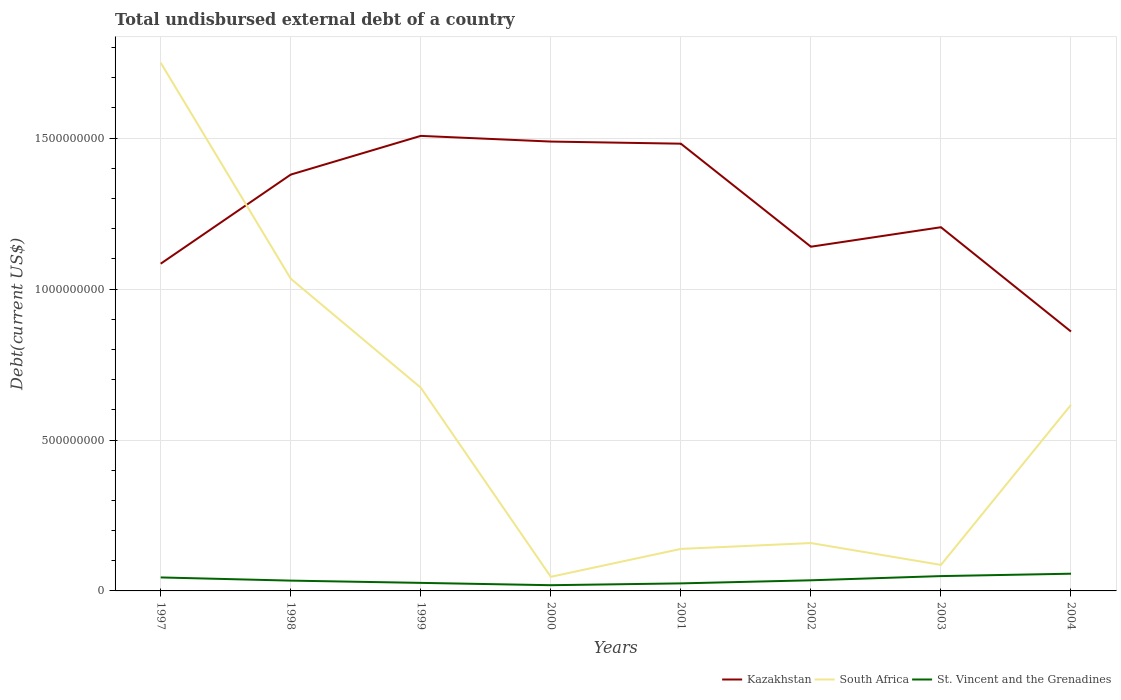Is the number of lines equal to the number of legend labels?
Ensure brevity in your answer.  Yes. Across all years, what is the maximum total undisbursed external debt in St. Vincent and the Grenadines?
Offer a terse response. 1.90e+07. In which year was the total undisbursed external debt in South Africa maximum?
Offer a terse response. 2000. What is the total total undisbursed external debt in South Africa in the graph?
Ensure brevity in your answer.  8.76e+08. What is the difference between the highest and the second highest total undisbursed external debt in Kazakhstan?
Your answer should be compact. 6.48e+08. How many years are there in the graph?
Keep it short and to the point. 8. What is the difference between two consecutive major ticks on the Y-axis?
Your answer should be very brief. 5.00e+08. Does the graph contain grids?
Offer a terse response. Yes. What is the title of the graph?
Give a very brief answer. Total undisbursed external debt of a country. Does "Sao Tome and Principe" appear as one of the legend labels in the graph?
Ensure brevity in your answer.  No. What is the label or title of the X-axis?
Provide a succinct answer. Years. What is the label or title of the Y-axis?
Offer a very short reply. Debt(current US$). What is the Debt(current US$) in Kazakhstan in 1997?
Your answer should be compact. 1.08e+09. What is the Debt(current US$) of South Africa in 1997?
Make the answer very short. 1.75e+09. What is the Debt(current US$) in St. Vincent and the Grenadines in 1997?
Keep it short and to the point. 4.47e+07. What is the Debt(current US$) in Kazakhstan in 1998?
Give a very brief answer. 1.38e+09. What is the Debt(current US$) in South Africa in 1998?
Provide a short and direct response. 1.03e+09. What is the Debt(current US$) of St. Vincent and the Grenadines in 1998?
Provide a succinct answer. 3.41e+07. What is the Debt(current US$) in Kazakhstan in 1999?
Offer a very short reply. 1.51e+09. What is the Debt(current US$) in South Africa in 1999?
Offer a terse response. 6.73e+08. What is the Debt(current US$) of St. Vincent and the Grenadines in 1999?
Offer a very short reply. 2.66e+07. What is the Debt(current US$) of Kazakhstan in 2000?
Provide a short and direct response. 1.49e+09. What is the Debt(current US$) of South Africa in 2000?
Give a very brief answer. 4.67e+07. What is the Debt(current US$) in St. Vincent and the Grenadines in 2000?
Your answer should be compact. 1.90e+07. What is the Debt(current US$) of Kazakhstan in 2001?
Make the answer very short. 1.48e+09. What is the Debt(current US$) of South Africa in 2001?
Provide a succinct answer. 1.39e+08. What is the Debt(current US$) of St. Vincent and the Grenadines in 2001?
Give a very brief answer. 2.50e+07. What is the Debt(current US$) in Kazakhstan in 2002?
Provide a succinct answer. 1.14e+09. What is the Debt(current US$) of South Africa in 2002?
Offer a terse response. 1.59e+08. What is the Debt(current US$) in St. Vincent and the Grenadines in 2002?
Offer a very short reply. 3.52e+07. What is the Debt(current US$) in Kazakhstan in 2003?
Your answer should be very brief. 1.20e+09. What is the Debt(current US$) of South Africa in 2003?
Your answer should be compact. 8.62e+07. What is the Debt(current US$) in St. Vincent and the Grenadines in 2003?
Provide a succinct answer. 4.91e+07. What is the Debt(current US$) of Kazakhstan in 2004?
Offer a terse response. 8.59e+08. What is the Debt(current US$) in South Africa in 2004?
Your answer should be very brief. 6.16e+08. What is the Debt(current US$) of St. Vincent and the Grenadines in 2004?
Ensure brevity in your answer.  5.70e+07. Across all years, what is the maximum Debt(current US$) in Kazakhstan?
Ensure brevity in your answer.  1.51e+09. Across all years, what is the maximum Debt(current US$) in South Africa?
Keep it short and to the point. 1.75e+09. Across all years, what is the maximum Debt(current US$) of St. Vincent and the Grenadines?
Your response must be concise. 5.70e+07. Across all years, what is the minimum Debt(current US$) in Kazakhstan?
Your answer should be compact. 8.59e+08. Across all years, what is the minimum Debt(current US$) in South Africa?
Provide a short and direct response. 4.67e+07. Across all years, what is the minimum Debt(current US$) in St. Vincent and the Grenadines?
Your answer should be compact. 1.90e+07. What is the total Debt(current US$) in Kazakhstan in the graph?
Offer a terse response. 1.01e+1. What is the total Debt(current US$) of South Africa in the graph?
Keep it short and to the point. 4.50e+09. What is the total Debt(current US$) in St. Vincent and the Grenadines in the graph?
Ensure brevity in your answer.  2.91e+08. What is the difference between the Debt(current US$) in Kazakhstan in 1997 and that in 1998?
Offer a terse response. -2.95e+08. What is the difference between the Debt(current US$) in South Africa in 1997 and that in 1998?
Your answer should be compact. 7.16e+08. What is the difference between the Debt(current US$) in St. Vincent and the Grenadines in 1997 and that in 1998?
Your answer should be compact. 1.05e+07. What is the difference between the Debt(current US$) in Kazakhstan in 1997 and that in 1999?
Give a very brief answer. -4.23e+08. What is the difference between the Debt(current US$) of South Africa in 1997 and that in 1999?
Give a very brief answer. 1.08e+09. What is the difference between the Debt(current US$) in St. Vincent and the Grenadines in 1997 and that in 1999?
Your response must be concise. 1.80e+07. What is the difference between the Debt(current US$) in Kazakhstan in 1997 and that in 2000?
Your response must be concise. -4.05e+08. What is the difference between the Debt(current US$) of South Africa in 1997 and that in 2000?
Provide a succinct answer. 1.70e+09. What is the difference between the Debt(current US$) in St. Vincent and the Grenadines in 1997 and that in 2000?
Your answer should be compact. 2.57e+07. What is the difference between the Debt(current US$) in Kazakhstan in 1997 and that in 2001?
Your answer should be compact. -3.98e+08. What is the difference between the Debt(current US$) of South Africa in 1997 and that in 2001?
Offer a terse response. 1.61e+09. What is the difference between the Debt(current US$) in St. Vincent and the Grenadines in 1997 and that in 2001?
Your response must be concise. 1.97e+07. What is the difference between the Debt(current US$) in Kazakhstan in 1997 and that in 2002?
Give a very brief answer. -5.63e+07. What is the difference between the Debt(current US$) in South Africa in 1997 and that in 2002?
Give a very brief answer. 1.59e+09. What is the difference between the Debt(current US$) in St. Vincent and the Grenadines in 1997 and that in 2002?
Offer a very short reply. 9.50e+06. What is the difference between the Debt(current US$) of Kazakhstan in 1997 and that in 2003?
Provide a short and direct response. -1.21e+08. What is the difference between the Debt(current US$) of South Africa in 1997 and that in 2003?
Make the answer very short. 1.66e+09. What is the difference between the Debt(current US$) of St. Vincent and the Grenadines in 1997 and that in 2003?
Your response must be concise. -4.47e+06. What is the difference between the Debt(current US$) of Kazakhstan in 1997 and that in 2004?
Offer a terse response. 2.25e+08. What is the difference between the Debt(current US$) of South Africa in 1997 and that in 2004?
Your answer should be compact. 1.13e+09. What is the difference between the Debt(current US$) of St. Vincent and the Grenadines in 1997 and that in 2004?
Give a very brief answer. -1.24e+07. What is the difference between the Debt(current US$) in Kazakhstan in 1998 and that in 1999?
Provide a short and direct response. -1.28e+08. What is the difference between the Debt(current US$) of South Africa in 1998 and that in 1999?
Give a very brief answer. 3.61e+08. What is the difference between the Debt(current US$) of St. Vincent and the Grenadines in 1998 and that in 1999?
Give a very brief answer. 7.50e+06. What is the difference between the Debt(current US$) in Kazakhstan in 1998 and that in 2000?
Give a very brief answer. -1.09e+08. What is the difference between the Debt(current US$) in South Africa in 1998 and that in 2000?
Provide a succinct answer. 9.88e+08. What is the difference between the Debt(current US$) of St. Vincent and the Grenadines in 1998 and that in 2000?
Keep it short and to the point. 1.52e+07. What is the difference between the Debt(current US$) in Kazakhstan in 1998 and that in 2001?
Your response must be concise. -1.02e+08. What is the difference between the Debt(current US$) in South Africa in 1998 and that in 2001?
Ensure brevity in your answer.  8.95e+08. What is the difference between the Debt(current US$) of St. Vincent and the Grenadines in 1998 and that in 2001?
Your answer should be compact. 9.16e+06. What is the difference between the Debt(current US$) of Kazakhstan in 1998 and that in 2002?
Provide a succinct answer. 2.39e+08. What is the difference between the Debt(current US$) of South Africa in 1998 and that in 2002?
Your answer should be very brief. 8.76e+08. What is the difference between the Debt(current US$) in St. Vincent and the Grenadines in 1998 and that in 2002?
Your answer should be very brief. -1.04e+06. What is the difference between the Debt(current US$) of Kazakhstan in 1998 and that in 2003?
Ensure brevity in your answer.  1.74e+08. What is the difference between the Debt(current US$) in South Africa in 1998 and that in 2003?
Provide a succinct answer. 9.48e+08. What is the difference between the Debt(current US$) in St. Vincent and the Grenadines in 1998 and that in 2003?
Offer a terse response. -1.50e+07. What is the difference between the Debt(current US$) of Kazakhstan in 1998 and that in 2004?
Your answer should be very brief. 5.20e+08. What is the difference between the Debt(current US$) of South Africa in 1998 and that in 2004?
Give a very brief answer. 4.18e+08. What is the difference between the Debt(current US$) in St. Vincent and the Grenadines in 1998 and that in 2004?
Your response must be concise. -2.29e+07. What is the difference between the Debt(current US$) of Kazakhstan in 1999 and that in 2000?
Your answer should be compact. 1.88e+07. What is the difference between the Debt(current US$) of South Africa in 1999 and that in 2000?
Your answer should be compact. 6.27e+08. What is the difference between the Debt(current US$) in St. Vincent and the Grenadines in 1999 and that in 2000?
Ensure brevity in your answer.  7.69e+06. What is the difference between the Debt(current US$) of Kazakhstan in 1999 and that in 2001?
Offer a very short reply. 2.59e+07. What is the difference between the Debt(current US$) of South Africa in 1999 and that in 2001?
Offer a terse response. 5.34e+08. What is the difference between the Debt(current US$) in St. Vincent and the Grenadines in 1999 and that in 2001?
Offer a very short reply. 1.66e+06. What is the difference between the Debt(current US$) in Kazakhstan in 1999 and that in 2002?
Provide a short and direct response. 3.67e+08. What is the difference between the Debt(current US$) of South Africa in 1999 and that in 2002?
Your response must be concise. 5.15e+08. What is the difference between the Debt(current US$) in St. Vincent and the Grenadines in 1999 and that in 2002?
Keep it short and to the point. -8.54e+06. What is the difference between the Debt(current US$) in Kazakhstan in 1999 and that in 2003?
Ensure brevity in your answer.  3.03e+08. What is the difference between the Debt(current US$) of South Africa in 1999 and that in 2003?
Keep it short and to the point. 5.87e+08. What is the difference between the Debt(current US$) of St. Vincent and the Grenadines in 1999 and that in 2003?
Offer a terse response. -2.25e+07. What is the difference between the Debt(current US$) of Kazakhstan in 1999 and that in 2004?
Make the answer very short. 6.48e+08. What is the difference between the Debt(current US$) in South Africa in 1999 and that in 2004?
Your response must be concise. 5.69e+07. What is the difference between the Debt(current US$) of St. Vincent and the Grenadines in 1999 and that in 2004?
Offer a terse response. -3.04e+07. What is the difference between the Debt(current US$) of Kazakhstan in 2000 and that in 2001?
Your answer should be very brief. 7.06e+06. What is the difference between the Debt(current US$) of South Africa in 2000 and that in 2001?
Your response must be concise. -9.24e+07. What is the difference between the Debt(current US$) of St. Vincent and the Grenadines in 2000 and that in 2001?
Keep it short and to the point. -6.02e+06. What is the difference between the Debt(current US$) in Kazakhstan in 2000 and that in 2002?
Keep it short and to the point. 3.48e+08. What is the difference between the Debt(current US$) of South Africa in 2000 and that in 2002?
Make the answer very short. -1.12e+08. What is the difference between the Debt(current US$) in St. Vincent and the Grenadines in 2000 and that in 2002?
Your answer should be very brief. -1.62e+07. What is the difference between the Debt(current US$) in Kazakhstan in 2000 and that in 2003?
Your answer should be very brief. 2.84e+08. What is the difference between the Debt(current US$) in South Africa in 2000 and that in 2003?
Give a very brief answer. -3.94e+07. What is the difference between the Debt(current US$) in St. Vincent and the Grenadines in 2000 and that in 2003?
Provide a short and direct response. -3.02e+07. What is the difference between the Debt(current US$) of Kazakhstan in 2000 and that in 2004?
Offer a very short reply. 6.29e+08. What is the difference between the Debt(current US$) in South Africa in 2000 and that in 2004?
Offer a very short reply. -5.70e+08. What is the difference between the Debt(current US$) of St. Vincent and the Grenadines in 2000 and that in 2004?
Your answer should be compact. -3.81e+07. What is the difference between the Debt(current US$) of Kazakhstan in 2001 and that in 2002?
Offer a terse response. 3.41e+08. What is the difference between the Debt(current US$) of South Africa in 2001 and that in 2002?
Offer a very short reply. -1.94e+07. What is the difference between the Debt(current US$) in St. Vincent and the Grenadines in 2001 and that in 2002?
Make the answer very short. -1.02e+07. What is the difference between the Debt(current US$) in Kazakhstan in 2001 and that in 2003?
Your answer should be compact. 2.77e+08. What is the difference between the Debt(current US$) of South Africa in 2001 and that in 2003?
Provide a succinct answer. 5.30e+07. What is the difference between the Debt(current US$) of St. Vincent and the Grenadines in 2001 and that in 2003?
Your answer should be very brief. -2.42e+07. What is the difference between the Debt(current US$) of Kazakhstan in 2001 and that in 2004?
Provide a succinct answer. 6.22e+08. What is the difference between the Debt(current US$) of South Africa in 2001 and that in 2004?
Make the answer very short. -4.77e+08. What is the difference between the Debt(current US$) of St. Vincent and the Grenadines in 2001 and that in 2004?
Your answer should be compact. -3.21e+07. What is the difference between the Debt(current US$) of Kazakhstan in 2002 and that in 2003?
Ensure brevity in your answer.  -6.46e+07. What is the difference between the Debt(current US$) of South Africa in 2002 and that in 2003?
Keep it short and to the point. 7.24e+07. What is the difference between the Debt(current US$) in St. Vincent and the Grenadines in 2002 and that in 2003?
Your answer should be very brief. -1.40e+07. What is the difference between the Debt(current US$) in Kazakhstan in 2002 and that in 2004?
Provide a succinct answer. 2.81e+08. What is the difference between the Debt(current US$) in South Africa in 2002 and that in 2004?
Offer a terse response. -4.58e+08. What is the difference between the Debt(current US$) of St. Vincent and the Grenadines in 2002 and that in 2004?
Provide a short and direct response. -2.19e+07. What is the difference between the Debt(current US$) in Kazakhstan in 2003 and that in 2004?
Your response must be concise. 3.46e+08. What is the difference between the Debt(current US$) in South Africa in 2003 and that in 2004?
Keep it short and to the point. -5.30e+08. What is the difference between the Debt(current US$) in St. Vincent and the Grenadines in 2003 and that in 2004?
Keep it short and to the point. -7.89e+06. What is the difference between the Debt(current US$) of Kazakhstan in 1997 and the Debt(current US$) of South Africa in 1998?
Offer a very short reply. 4.96e+07. What is the difference between the Debt(current US$) of Kazakhstan in 1997 and the Debt(current US$) of St. Vincent and the Grenadines in 1998?
Your answer should be very brief. 1.05e+09. What is the difference between the Debt(current US$) in South Africa in 1997 and the Debt(current US$) in St. Vincent and the Grenadines in 1998?
Give a very brief answer. 1.72e+09. What is the difference between the Debt(current US$) in Kazakhstan in 1997 and the Debt(current US$) in South Africa in 1999?
Provide a succinct answer. 4.11e+08. What is the difference between the Debt(current US$) in Kazakhstan in 1997 and the Debt(current US$) in St. Vincent and the Grenadines in 1999?
Keep it short and to the point. 1.06e+09. What is the difference between the Debt(current US$) of South Africa in 1997 and the Debt(current US$) of St. Vincent and the Grenadines in 1999?
Offer a very short reply. 1.72e+09. What is the difference between the Debt(current US$) of Kazakhstan in 1997 and the Debt(current US$) of South Africa in 2000?
Give a very brief answer. 1.04e+09. What is the difference between the Debt(current US$) in Kazakhstan in 1997 and the Debt(current US$) in St. Vincent and the Grenadines in 2000?
Keep it short and to the point. 1.07e+09. What is the difference between the Debt(current US$) of South Africa in 1997 and the Debt(current US$) of St. Vincent and the Grenadines in 2000?
Provide a succinct answer. 1.73e+09. What is the difference between the Debt(current US$) in Kazakhstan in 1997 and the Debt(current US$) in South Africa in 2001?
Ensure brevity in your answer.  9.45e+08. What is the difference between the Debt(current US$) in Kazakhstan in 1997 and the Debt(current US$) in St. Vincent and the Grenadines in 2001?
Offer a terse response. 1.06e+09. What is the difference between the Debt(current US$) of South Africa in 1997 and the Debt(current US$) of St. Vincent and the Grenadines in 2001?
Provide a succinct answer. 1.73e+09. What is the difference between the Debt(current US$) in Kazakhstan in 1997 and the Debt(current US$) in South Africa in 2002?
Keep it short and to the point. 9.26e+08. What is the difference between the Debt(current US$) of Kazakhstan in 1997 and the Debt(current US$) of St. Vincent and the Grenadines in 2002?
Provide a succinct answer. 1.05e+09. What is the difference between the Debt(current US$) in South Africa in 1997 and the Debt(current US$) in St. Vincent and the Grenadines in 2002?
Keep it short and to the point. 1.71e+09. What is the difference between the Debt(current US$) of Kazakhstan in 1997 and the Debt(current US$) of South Africa in 2003?
Give a very brief answer. 9.98e+08. What is the difference between the Debt(current US$) in Kazakhstan in 1997 and the Debt(current US$) in St. Vincent and the Grenadines in 2003?
Keep it short and to the point. 1.03e+09. What is the difference between the Debt(current US$) in South Africa in 1997 and the Debt(current US$) in St. Vincent and the Grenadines in 2003?
Offer a very short reply. 1.70e+09. What is the difference between the Debt(current US$) in Kazakhstan in 1997 and the Debt(current US$) in South Africa in 2004?
Keep it short and to the point. 4.68e+08. What is the difference between the Debt(current US$) of Kazakhstan in 1997 and the Debt(current US$) of St. Vincent and the Grenadines in 2004?
Your answer should be compact. 1.03e+09. What is the difference between the Debt(current US$) in South Africa in 1997 and the Debt(current US$) in St. Vincent and the Grenadines in 2004?
Make the answer very short. 1.69e+09. What is the difference between the Debt(current US$) of Kazakhstan in 1998 and the Debt(current US$) of South Africa in 1999?
Ensure brevity in your answer.  7.06e+08. What is the difference between the Debt(current US$) in Kazakhstan in 1998 and the Debt(current US$) in St. Vincent and the Grenadines in 1999?
Provide a succinct answer. 1.35e+09. What is the difference between the Debt(current US$) in South Africa in 1998 and the Debt(current US$) in St. Vincent and the Grenadines in 1999?
Provide a short and direct response. 1.01e+09. What is the difference between the Debt(current US$) of Kazakhstan in 1998 and the Debt(current US$) of South Africa in 2000?
Ensure brevity in your answer.  1.33e+09. What is the difference between the Debt(current US$) in Kazakhstan in 1998 and the Debt(current US$) in St. Vincent and the Grenadines in 2000?
Give a very brief answer. 1.36e+09. What is the difference between the Debt(current US$) in South Africa in 1998 and the Debt(current US$) in St. Vincent and the Grenadines in 2000?
Provide a succinct answer. 1.02e+09. What is the difference between the Debt(current US$) of Kazakhstan in 1998 and the Debt(current US$) of South Africa in 2001?
Your response must be concise. 1.24e+09. What is the difference between the Debt(current US$) in Kazakhstan in 1998 and the Debt(current US$) in St. Vincent and the Grenadines in 2001?
Give a very brief answer. 1.35e+09. What is the difference between the Debt(current US$) of South Africa in 1998 and the Debt(current US$) of St. Vincent and the Grenadines in 2001?
Offer a very short reply. 1.01e+09. What is the difference between the Debt(current US$) in Kazakhstan in 1998 and the Debt(current US$) in South Africa in 2002?
Keep it short and to the point. 1.22e+09. What is the difference between the Debt(current US$) of Kazakhstan in 1998 and the Debt(current US$) of St. Vincent and the Grenadines in 2002?
Your answer should be very brief. 1.34e+09. What is the difference between the Debt(current US$) in South Africa in 1998 and the Debt(current US$) in St. Vincent and the Grenadines in 2002?
Offer a very short reply. 9.99e+08. What is the difference between the Debt(current US$) in Kazakhstan in 1998 and the Debt(current US$) in South Africa in 2003?
Give a very brief answer. 1.29e+09. What is the difference between the Debt(current US$) in Kazakhstan in 1998 and the Debt(current US$) in St. Vincent and the Grenadines in 2003?
Give a very brief answer. 1.33e+09. What is the difference between the Debt(current US$) of South Africa in 1998 and the Debt(current US$) of St. Vincent and the Grenadines in 2003?
Give a very brief answer. 9.85e+08. What is the difference between the Debt(current US$) of Kazakhstan in 1998 and the Debt(current US$) of South Africa in 2004?
Provide a succinct answer. 7.63e+08. What is the difference between the Debt(current US$) of Kazakhstan in 1998 and the Debt(current US$) of St. Vincent and the Grenadines in 2004?
Provide a short and direct response. 1.32e+09. What is the difference between the Debt(current US$) in South Africa in 1998 and the Debt(current US$) in St. Vincent and the Grenadines in 2004?
Offer a terse response. 9.77e+08. What is the difference between the Debt(current US$) of Kazakhstan in 1999 and the Debt(current US$) of South Africa in 2000?
Keep it short and to the point. 1.46e+09. What is the difference between the Debt(current US$) of Kazakhstan in 1999 and the Debt(current US$) of St. Vincent and the Grenadines in 2000?
Give a very brief answer. 1.49e+09. What is the difference between the Debt(current US$) in South Africa in 1999 and the Debt(current US$) in St. Vincent and the Grenadines in 2000?
Provide a succinct answer. 6.54e+08. What is the difference between the Debt(current US$) in Kazakhstan in 1999 and the Debt(current US$) in South Africa in 2001?
Ensure brevity in your answer.  1.37e+09. What is the difference between the Debt(current US$) in Kazakhstan in 1999 and the Debt(current US$) in St. Vincent and the Grenadines in 2001?
Give a very brief answer. 1.48e+09. What is the difference between the Debt(current US$) of South Africa in 1999 and the Debt(current US$) of St. Vincent and the Grenadines in 2001?
Provide a short and direct response. 6.48e+08. What is the difference between the Debt(current US$) of Kazakhstan in 1999 and the Debt(current US$) of South Africa in 2002?
Make the answer very short. 1.35e+09. What is the difference between the Debt(current US$) of Kazakhstan in 1999 and the Debt(current US$) of St. Vincent and the Grenadines in 2002?
Ensure brevity in your answer.  1.47e+09. What is the difference between the Debt(current US$) of South Africa in 1999 and the Debt(current US$) of St. Vincent and the Grenadines in 2002?
Provide a short and direct response. 6.38e+08. What is the difference between the Debt(current US$) in Kazakhstan in 1999 and the Debt(current US$) in South Africa in 2003?
Your answer should be very brief. 1.42e+09. What is the difference between the Debt(current US$) in Kazakhstan in 1999 and the Debt(current US$) in St. Vincent and the Grenadines in 2003?
Provide a succinct answer. 1.46e+09. What is the difference between the Debt(current US$) of South Africa in 1999 and the Debt(current US$) of St. Vincent and the Grenadines in 2003?
Your answer should be very brief. 6.24e+08. What is the difference between the Debt(current US$) of Kazakhstan in 1999 and the Debt(current US$) of South Africa in 2004?
Make the answer very short. 8.91e+08. What is the difference between the Debt(current US$) of Kazakhstan in 1999 and the Debt(current US$) of St. Vincent and the Grenadines in 2004?
Offer a terse response. 1.45e+09. What is the difference between the Debt(current US$) in South Africa in 1999 and the Debt(current US$) in St. Vincent and the Grenadines in 2004?
Ensure brevity in your answer.  6.16e+08. What is the difference between the Debt(current US$) in Kazakhstan in 2000 and the Debt(current US$) in South Africa in 2001?
Provide a short and direct response. 1.35e+09. What is the difference between the Debt(current US$) of Kazakhstan in 2000 and the Debt(current US$) of St. Vincent and the Grenadines in 2001?
Your answer should be very brief. 1.46e+09. What is the difference between the Debt(current US$) of South Africa in 2000 and the Debt(current US$) of St. Vincent and the Grenadines in 2001?
Provide a short and direct response. 2.18e+07. What is the difference between the Debt(current US$) of Kazakhstan in 2000 and the Debt(current US$) of South Africa in 2002?
Provide a succinct answer. 1.33e+09. What is the difference between the Debt(current US$) in Kazakhstan in 2000 and the Debt(current US$) in St. Vincent and the Grenadines in 2002?
Ensure brevity in your answer.  1.45e+09. What is the difference between the Debt(current US$) in South Africa in 2000 and the Debt(current US$) in St. Vincent and the Grenadines in 2002?
Offer a very short reply. 1.16e+07. What is the difference between the Debt(current US$) of Kazakhstan in 2000 and the Debt(current US$) of South Africa in 2003?
Your answer should be very brief. 1.40e+09. What is the difference between the Debt(current US$) in Kazakhstan in 2000 and the Debt(current US$) in St. Vincent and the Grenadines in 2003?
Keep it short and to the point. 1.44e+09. What is the difference between the Debt(current US$) in South Africa in 2000 and the Debt(current US$) in St. Vincent and the Grenadines in 2003?
Your answer should be very brief. -2.40e+06. What is the difference between the Debt(current US$) in Kazakhstan in 2000 and the Debt(current US$) in South Africa in 2004?
Make the answer very short. 8.72e+08. What is the difference between the Debt(current US$) in Kazakhstan in 2000 and the Debt(current US$) in St. Vincent and the Grenadines in 2004?
Provide a succinct answer. 1.43e+09. What is the difference between the Debt(current US$) of South Africa in 2000 and the Debt(current US$) of St. Vincent and the Grenadines in 2004?
Offer a very short reply. -1.03e+07. What is the difference between the Debt(current US$) in Kazakhstan in 2001 and the Debt(current US$) in South Africa in 2002?
Offer a terse response. 1.32e+09. What is the difference between the Debt(current US$) in Kazakhstan in 2001 and the Debt(current US$) in St. Vincent and the Grenadines in 2002?
Give a very brief answer. 1.45e+09. What is the difference between the Debt(current US$) in South Africa in 2001 and the Debt(current US$) in St. Vincent and the Grenadines in 2002?
Keep it short and to the point. 1.04e+08. What is the difference between the Debt(current US$) in Kazakhstan in 2001 and the Debt(current US$) in South Africa in 2003?
Your response must be concise. 1.40e+09. What is the difference between the Debt(current US$) of Kazakhstan in 2001 and the Debt(current US$) of St. Vincent and the Grenadines in 2003?
Your answer should be compact. 1.43e+09. What is the difference between the Debt(current US$) in South Africa in 2001 and the Debt(current US$) in St. Vincent and the Grenadines in 2003?
Provide a short and direct response. 9.00e+07. What is the difference between the Debt(current US$) of Kazakhstan in 2001 and the Debt(current US$) of South Africa in 2004?
Offer a terse response. 8.65e+08. What is the difference between the Debt(current US$) of Kazakhstan in 2001 and the Debt(current US$) of St. Vincent and the Grenadines in 2004?
Give a very brief answer. 1.42e+09. What is the difference between the Debt(current US$) in South Africa in 2001 and the Debt(current US$) in St. Vincent and the Grenadines in 2004?
Provide a short and direct response. 8.21e+07. What is the difference between the Debt(current US$) of Kazakhstan in 2002 and the Debt(current US$) of South Africa in 2003?
Your response must be concise. 1.05e+09. What is the difference between the Debt(current US$) in Kazakhstan in 2002 and the Debt(current US$) in St. Vincent and the Grenadines in 2003?
Make the answer very short. 1.09e+09. What is the difference between the Debt(current US$) of South Africa in 2002 and the Debt(current US$) of St. Vincent and the Grenadines in 2003?
Provide a succinct answer. 1.09e+08. What is the difference between the Debt(current US$) in Kazakhstan in 2002 and the Debt(current US$) in South Africa in 2004?
Offer a terse response. 5.24e+08. What is the difference between the Debt(current US$) of Kazakhstan in 2002 and the Debt(current US$) of St. Vincent and the Grenadines in 2004?
Your answer should be very brief. 1.08e+09. What is the difference between the Debt(current US$) of South Africa in 2002 and the Debt(current US$) of St. Vincent and the Grenadines in 2004?
Offer a terse response. 1.02e+08. What is the difference between the Debt(current US$) in Kazakhstan in 2003 and the Debt(current US$) in South Africa in 2004?
Provide a succinct answer. 5.89e+08. What is the difference between the Debt(current US$) of Kazakhstan in 2003 and the Debt(current US$) of St. Vincent and the Grenadines in 2004?
Your answer should be compact. 1.15e+09. What is the difference between the Debt(current US$) of South Africa in 2003 and the Debt(current US$) of St. Vincent and the Grenadines in 2004?
Offer a terse response. 2.91e+07. What is the average Debt(current US$) in Kazakhstan per year?
Offer a very short reply. 1.27e+09. What is the average Debt(current US$) in South Africa per year?
Your answer should be compact. 5.63e+08. What is the average Debt(current US$) in St. Vincent and the Grenadines per year?
Your response must be concise. 3.63e+07. In the year 1997, what is the difference between the Debt(current US$) in Kazakhstan and Debt(current US$) in South Africa?
Your answer should be very brief. -6.66e+08. In the year 1997, what is the difference between the Debt(current US$) of Kazakhstan and Debt(current US$) of St. Vincent and the Grenadines?
Provide a short and direct response. 1.04e+09. In the year 1997, what is the difference between the Debt(current US$) of South Africa and Debt(current US$) of St. Vincent and the Grenadines?
Give a very brief answer. 1.71e+09. In the year 1998, what is the difference between the Debt(current US$) of Kazakhstan and Debt(current US$) of South Africa?
Make the answer very short. 3.45e+08. In the year 1998, what is the difference between the Debt(current US$) in Kazakhstan and Debt(current US$) in St. Vincent and the Grenadines?
Provide a short and direct response. 1.35e+09. In the year 1998, what is the difference between the Debt(current US$) in South Africa and Debt(current US$) in St. Vincent and the Grenadines?
Give a very brief answer. 1.00e+09. In the year 1999, what is the difference between the Debt(current US$) in Kazakhstan and Debt(current US$) in South Africa?
Offer a very short reply. 8.34e+08. In the year 1999, what is the difference between the Debt(current US$) of Kazakhstan and Debt(current US$) of St. Vincent and the Grenadines?
Your response must be concise. 1.48e+09. In the year 1999, what is the difference between the Debt(current US$) in South Africa and Debt(current US$) in St. Vincent and the Grenadines?
Your answer should be compact. 6.47e+08. In the year 2000, what is the difference between the Debt(current US$) in Kazakhstan and Debt(current US$) in South Africa?
Make the answer very short. 1.44e+09. In the year 2000, what is the difference between the Debt(current US$) of Kazakhstan and Debt(current US$) of St. Vincent and the Grenadines?
Offer a terse response. 1.47e+09. In the year 2000, what is the difference between the Debt(current US$) in South Africa and Debt(current US$) in St. Vincent and the Grenadines?
Make the answer very short. 2.78e+07. In the year 2001, what is the difference between the Debt(current US$) of Kazakhstan and Debt(current US$) of South Africa?
Provide a succinct answer. 1.34e+09. In the year 2001, what is the difference between the Debt(current US$) of Kazakhstan and Debt(current US$) of St. Vincent and the Grenadines?
Make the answer very short. 1.46e+09. In the year 2001, what is the difference between the Debt(current US$) of South Africa and Debt(current US$) of St. Vincent and the Grenadines?
Your response must be concise. 1.14e+08. In the year 2002, what is the difference between the Debt(current US$) in Kazakhstan and Debt(current US$) in South Africa?
Your answer should be very brief. 9.82e+08. In the year 2002, what is the difference between the Debt(current US$) of Kazakhstan and Debt(current US$) of St. Vincent and the Grenadines?
Keep it short and to the point. 1.11e+09. In the year 2002, what is the difference between the Debt(current US$) of South Africa and Debt(current US$) of St. Vincent and the Grenadines?
Your answer should be very brief. 1.23e+08. In the year 2003, what is the difference between the Debt(current US$) in Kazakhstan and Debt(current US$) in South Africa?
Offer a terse response. 1.12e+09. In the year 2003, what is the difference between the Debt(current US$) of Kazakhstan and Debt(current US$) of St. Vincent and the Grenadines?
Keep it short and to the point. 1.16e+09. In the year 2003, what is the difference between the Debt(current US$) of South Africa and Debt(current US$) of St. Vincent and the Grenadines?
Provide a short and direct response. 3.70e+07. In the year 2004, what is the difference between the Debt(current US$) of Kazakhstan and Debt(current US$) of South Africa?
Keep it short and to the point. 2.43e+08. In the year 2004, what is the difference between the Debt(current US$) of Kazakhstan and Debt(current US$) of St. Vincent and the Grenadines?
Provide a succinct answer. 8.02e+08. In the year 2004, what is the difference between the Debt(current US$) in South Africa and Debt(current US$) in St. Vincent and the Grenadines?
Keep it short and to the point. 5.59e+08. What is the ratio of the Debt(current US$) in Kazakhstan in 1997 to that in 1998?
Your answer should be compact. 0.79. What is the ratio of the Debt(current US$) in South Africa in 1997 to that in 1998?
Offer a very short reply. 1.69. What is the ratio of the Debt(current US$) in St. Vincent and the Grenadines in 1997 to that in 1998?
Make the answer very short. 1.31. What is the ratio of the Debt(current US$) of Kazakhstan in 1997 to that in 1999?
Give a very brief answer. 0.72. What is the ratio of the Debt(current US$) in South Africa in 1997 to that in 1999?
Ensure brevity in your answer.  2.6. What is the ratio of the Debt(current US$) in St. Vincent and the Grenadines in 1997 to that in 1999?
Offer a terse response. 1.68. What is the ratio of the Debt(current US$) of Kazakhstan in 1997 to that in 2000?
Offer a very short reply. 0.73. What is the ratio of the Debt(current US$) in South Africa in 1997 to that in 2000?
Your response must be concise. 37.44. What is the ratio of the Debt(current US$) in St. Vincent and the Grenadines in 1997 to that in 2000?
Give a very brief answer. 2.36. What is the ratio of the Debt(current US$) in Kazakhstan in 1997 to that in 2001?
Your response must be concise. 0.73. What is the ratio of the Debt(current US$) in South Africa in 1997 to that in 2001?
Make the answer very short. 12.57. What is the ratio of the Debt(current US$) in St. Vincent and the Grenadines in 1997 to that in 2001?
Your answer should be very brief. 1.79. What is the ratio of the Debt(current US$) in Kazakhstan in 1997 to that in 2002?
Ensure brevity in your answer.  0.95. What is the ratio of the Debt(current US$) of South Africa in 1997 to that in 2002?
Ensure brevity in your answer.  11.04. What is the ratio of the Debt(current US$) of St. Vincent and the Grenadines in 1997 to that in 2002?
Keep it short and to the point. 1.27. What is the ratio of the Debt(current US$) of Kazakhstan in 1997 to that in 2003?
Give a very brief answer. 0.9. What is the ratio of the Debt(current US$) of South Africa in 1997 to that in 2003?
Keep it short and to the point. 20.31. What is the ratio of the Debt(current US$) in Kazakhstan in 1997 to that in 2004?
Your answer should be very brief. 1.26. What is the ratio of the Debt(current US$) in South Africa in 1997 to that in 2004?
Provide a succinct answer. 2.84. What is the ratio of the Debt(current US$) in St. Vincent and the Grenadines in 1997 to that in 2004?
Your answer should be compact. 0.78. What is the ratio of the Debt(current US$) of Kazakhstan in 1998 to that in 1999?
Your answer should be compact. 0.91. What is the ratio of the Debt(current US$) in South Africa in 1998 to that in 1999?
Make the answer very short. 1.54. What is the ratio of the Debt(current US$) in St. Vincent and the Grenadines in 1998 to that in 1999?
Ensure brevity in your answer.  1.28. What is the ratio of the Debt(current US$) of Kazakhstan in 1998 to that in 2000?
Offer a very short reply. 0.93. What is the ratio of the Debt(current US$) of South Africa in 1998 to that in 2000?
Your response must be concise. 22.13. What is the ratio of the Debt(current US$) in St. Vincent and the Grenadines in 1998 to that in 2000?
Your answer should be compact. 1.8. What is the ratio of the Debt(current US$) of Kazakhstan in 1998 to that in 2001?
Make the answer very short. 0.93. What is the ratio of the Debt(current US$) in South Africa in 1998 to that in 2001?
Offer a very short reply. 7.43. What is the ratio of the Debt(current US$) of St. Vincent and the Grenadines in 1998 to that in 2001?
Your response must be concise. 1.37. What is the ratio of the Debt(current US$) of Kazakhstan in 1998 to that in 2002?
Offer a terse response. 1.21. What is the ratio of the Debt(current US$) in South Africa in 1998 to that in 2002?
Provide a succinct answer. 6.52. What is the ratio of the Debt(current US$) of St. Vincent and the Grenadines in 1998 to that in 2002?
Keep it short and to the point. 0.97. What is the ratio of the Debt(current US$) of Kazakhstan in 1998 to that in 2003?
Provide a succinct answer. 1.14. What is the ratio of the Debt(current US$) in South Africa in 1998 to that in 2003?
Offer a terse response. 12. What is the ratio of the Debt(current US$) of St. Vincent and the Grenadines in 1998 to that in 2003?
Give a very brief answer. 0.69. What is the ratio of the Debt(current US$) in Kazakhstan in 1998 to that in 2004?
Offer a very short reply. 1.6. What is the ratio of the Debt(current US$) in South Africa in 1998 to that in 2004?
Give a very brief answer. 1.68. What is the ratio of the Debt(current US$) of St. Vincent and the Grenadines in 1998 to that in 2004?
Offer a very short reply. 0.6. What is the ratio of the Debt(current US$) in Kazakhstan in 1999 to that in 2000?
Give a very brief answer. 1.01. What is the ratio of the Debt(current US$) in South Africa in 1999 to that in 2000?
Keep it short and to the point. 14.4. What is the ratio of the Debt(current US$) of St. Vincent and the Grenadines in 1999 to that in 2000?
Offer a terse response. 1.41. What is the ratio of the Debt(current US$) in Kazakhstan in 1999 to that in 2001?
Your answer should be very brief. 1.02. What is the ratio of the Debt(current US$) in South Africa in 1999 to that in 2001?
Your answer should be very brief. 4.84. What is the ratio of the Debt(current US$) in St. Vincent and the Grenadines in 1999 to that in 2001?
Keep it short and to the point. 1.07. What is the ratio of the Debt(current US$) in Kazakhstan in 1999 to that in 2002?
Offer a terse response. 1.32. What is the ratio of the Debt(current US$) in South Africa in 1999 to that in 2002?
Give a very brief answer. 4.25. What is the ratio of the Debt(current US$) of St. Vincent and the Grenadines in 1999 to that in 2002?
Offer a very short reply. 0.76. What is the ratio of the Debt(current US$) in Kazakhstan in 1999 to that in 2003?
Your answer should be very brief. 1.25. What is the ratio of the Debt(current US$) of South Africa in 1999 to that in 2003?
Give a very brief answer. 7.81. What is the ratio of the Debt(current US$) in St. Vincent and the Grenadines in 1999 to that in 2003?
Your answer should be compact. 0.54. What is the ratio of the Debt(current US$) in Kazakhstan in 1999 to that in 2004?
Offer a very short reply. 1.75. What is the ratio of the Debt(current US$) of South Africa in 1999 to that in 2004?
Keep it short and to the point. 1.09. What is the ratio of the Debt(current US$) in St. Vincent and the Grenadines in 1999 to that in 2004?
Your answer should be very brief. 0.47. What is the ratio of the Debt(current US$) of South Africa in 2000 to that in 2001?
Make the answer very short. 0.34. What is the ratio of the Debt(current US$) of St. Vincent and the Grenadines in 2000 to that in 2001?
Provide a succinct answer. 0.76. What is the ratio of the Debt(current US$) in Kazakhstan in 2000 to that in 2002?
Provide a succinct answer. 1.31. What is the ratio of the Debt(current US$) in South Africa in 2000 to that in 2002?
Offer a terse response. 0.29. What is the ratio of the Debt(current US$) in St. Vincent and the Grenadines in 2000 to that in 2002?
Your answer should be compact. 0.54. What is the ratio of the Debt(current US$) in Kazakhstan in 2000 to that in 2003?
Keep it short and to the point. 1.24. What is the ratio of the Debt(current US$) in South Africa in 2000 to that in 2003?
Offer a terse response. 0.54. What is the ratio of the Debt(current US$) of St. Vincent and the Grenadines in 2000 to that in 2003?
Ensure brevity in your answer.  0.39. What is the ratio of the Debt(current US$) in Kazakhstan in 2000 to that in 2004?
Offer a terse response. 1.73. What is the ratio of the Debt(current US$) of South Africa in 2000 to that in 2004?
Your answer should be compact. 0.08. What is the ratio of the Debt(current US$) in St. Vincent and the Grenadines in 2000 to that in 2004?
Offer a very short reply. 0.33. What is the ratio of the Debt(current US$) in Kazakhstan in 2001 to that in 2002?
Make the answer very short. 1.3. What is the ratio of the Debt(current US$) of South Africa in 2001 to that in 2002?
Offer a very short reply. 0.88. What is the ratio of the Debt(current US$) of St. Vincent and the Grenadines in 2001 to that in 2002?
Offer a terse response. 0.71. What is the ratio of the Debt(current US$) of Kazakhstan in 2001 to that in 2003?
Offer a very short reply. 1.23. What is the ratio of the Debt(current US$) in South Africa in 2001 to that in 2003?
Give a very brief answer. 1.61. What is the ratio of the Debt(current US$) of St. Vincent and the Grenadines in 2001 to that in 2003?
Make the answer very short. 0.51. What is the ratio of the Debt(current US$) in Kazakhstan in 2001 to that in 2004?
Provide a succinct answer. 1.72. What is the ratio of the Debt(current US$) of South Africa in 2001 to that in 2004?
Provide a short and direct response. 0.23. What is the ratio of the Debt(current US$) of St. Vincent and the Grenadines in 2001 to that in 2004?
Keep it short and to the point. 0.44. What is the ratio of the Debt(current US$) in Kazakhstan in 2002 to that in 2003?
Your answer should be very brief. 0.95. What is the ratio of the Debt(current US$) of South Africa in 2002 to that in 2003?
Keep it short and to the point. 1.84. What is the ratio of the Debt(current US$) of St. Vincent and the Grenadines in 2002 to that in 2003?
Provide a short and direct response. 0.72. What is the ratio of the Debt(current US$) of Kazakhstan in 2002 to that in 2004?
Give a very brief answer. 1.33. What is the ratio of the Debt(current US$) in South Africa in 2002 to that in 2004?
Ensure brevity in your answer.  0.26. What is the ratio of the Debt(current US$) of St. Vincent and the Grenadines in 2002 to that in 2004?
Ensure brevity in your answer.  0.62. What is the ratio of the Debt(current US$) of Kazakhstan in 2003 to that in 2004?
Make the answer very short. 1.4. What is the ratio of the Debt(current US$) in South Africa in 2003 to that in 2004?
Your response must be concise. 0.14. What is the ratio of the Debt(current US$) in St. Vincent and the Grenadines in 2003 to that in 2004?
Offer a very short reply. 0.86. What is the difference between the highest and the second highest Debt(current US$) of Kazakhstan?
Keep it short and to the point. 1.88e+07. What is the difference between the highest and the second highest Debt(current US$) of South Africa?
Provide a short and direct response. 7.16e+08. What is the difference between the highest and the second highest Debt(current US$) in St. Vincent and the Grenadines?
Offer a very short reply. 7.89e+06. What is the difference between the highest and the lowest Debt(current US$) in Kazakhstan?
Ensure brevity in your answer.  6.48e+08. What is the difference between the highest and the lowest Debt(current US$) of South Africa?
Offer a terse response. 1.70e+09. What is the difference between the highest and the lowest Debt(current US$) in St. Vincent and the Grenadines?
Your answer should be very brief. 3.81e+07. 